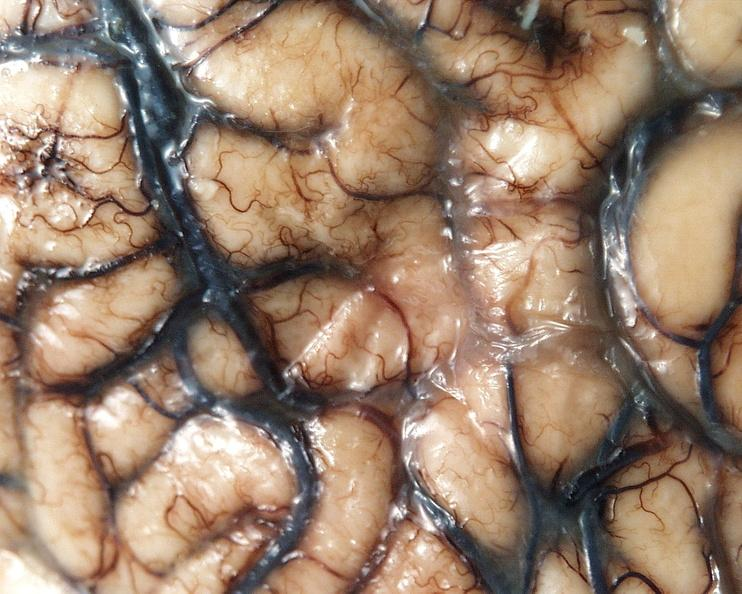s nervous present?
Answer the question using a single word or phrase. Yes 